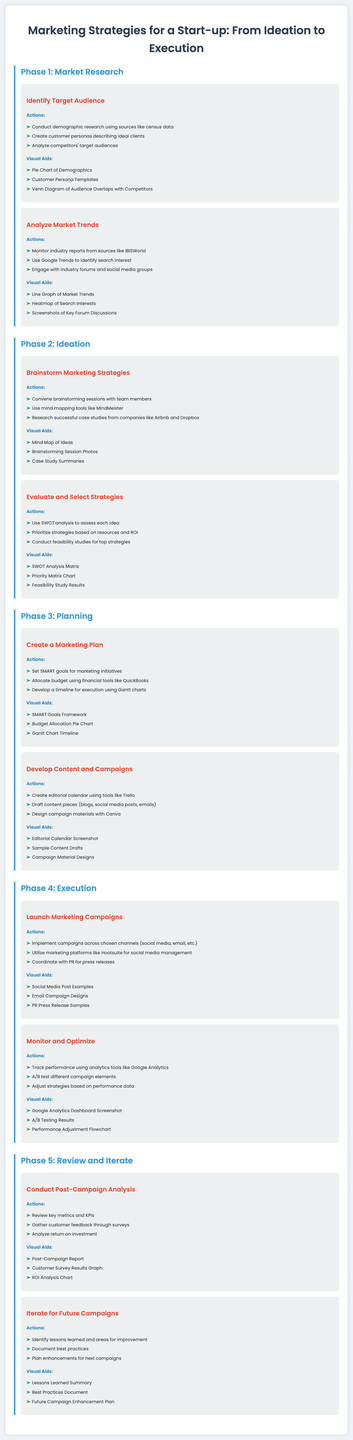What is the first phase of the marketing strategies? The first phase mentioned in the document is "Market Research."
Answer: Market Research How many steps are in the "Planning" phase? The "Planning" phase consists of two steps: "Create a Marketing Plan" and "Develop Content and Campaigns."
Answer: 2 What is one tool mentioned for creating customer personas? The document lists creating customer personas as an action under "Identify Target Audience," but does not specify a tool directly for this action.
Answer: Not specified Which phase includes "Monitor and Optimize"? "Monitor and Optimize" is part of the "Execution" phase.
Answer: Execution What type of chart is suggested for budget allocation? The document suggests using a "Budget Allocation Pie Chart" as a visual aid under "Create a Marketing Plan."
Answer: Budget Allocation Pie Chart What is the outcome of the "Conduct Post-Campaign Analysis" step? The outcomes include reviewing key metrics, gathering customer feedback, and analyzing return on investment.
Answer: Key metrics, customer feedback, ROI How many visual aids are suggested in the "Brainstorm Marketing Strategies" step? There are three visual aids suggested in this step: "Mind Map of Ideas," "Brainstorming Session Photos," and "Case Study Summaries."
Answer: 3 Which marketing platform is mentioned for social media management? The document mentions "Hootsuite" as a marketing platform for social media management.
Answer: Hootsuite 